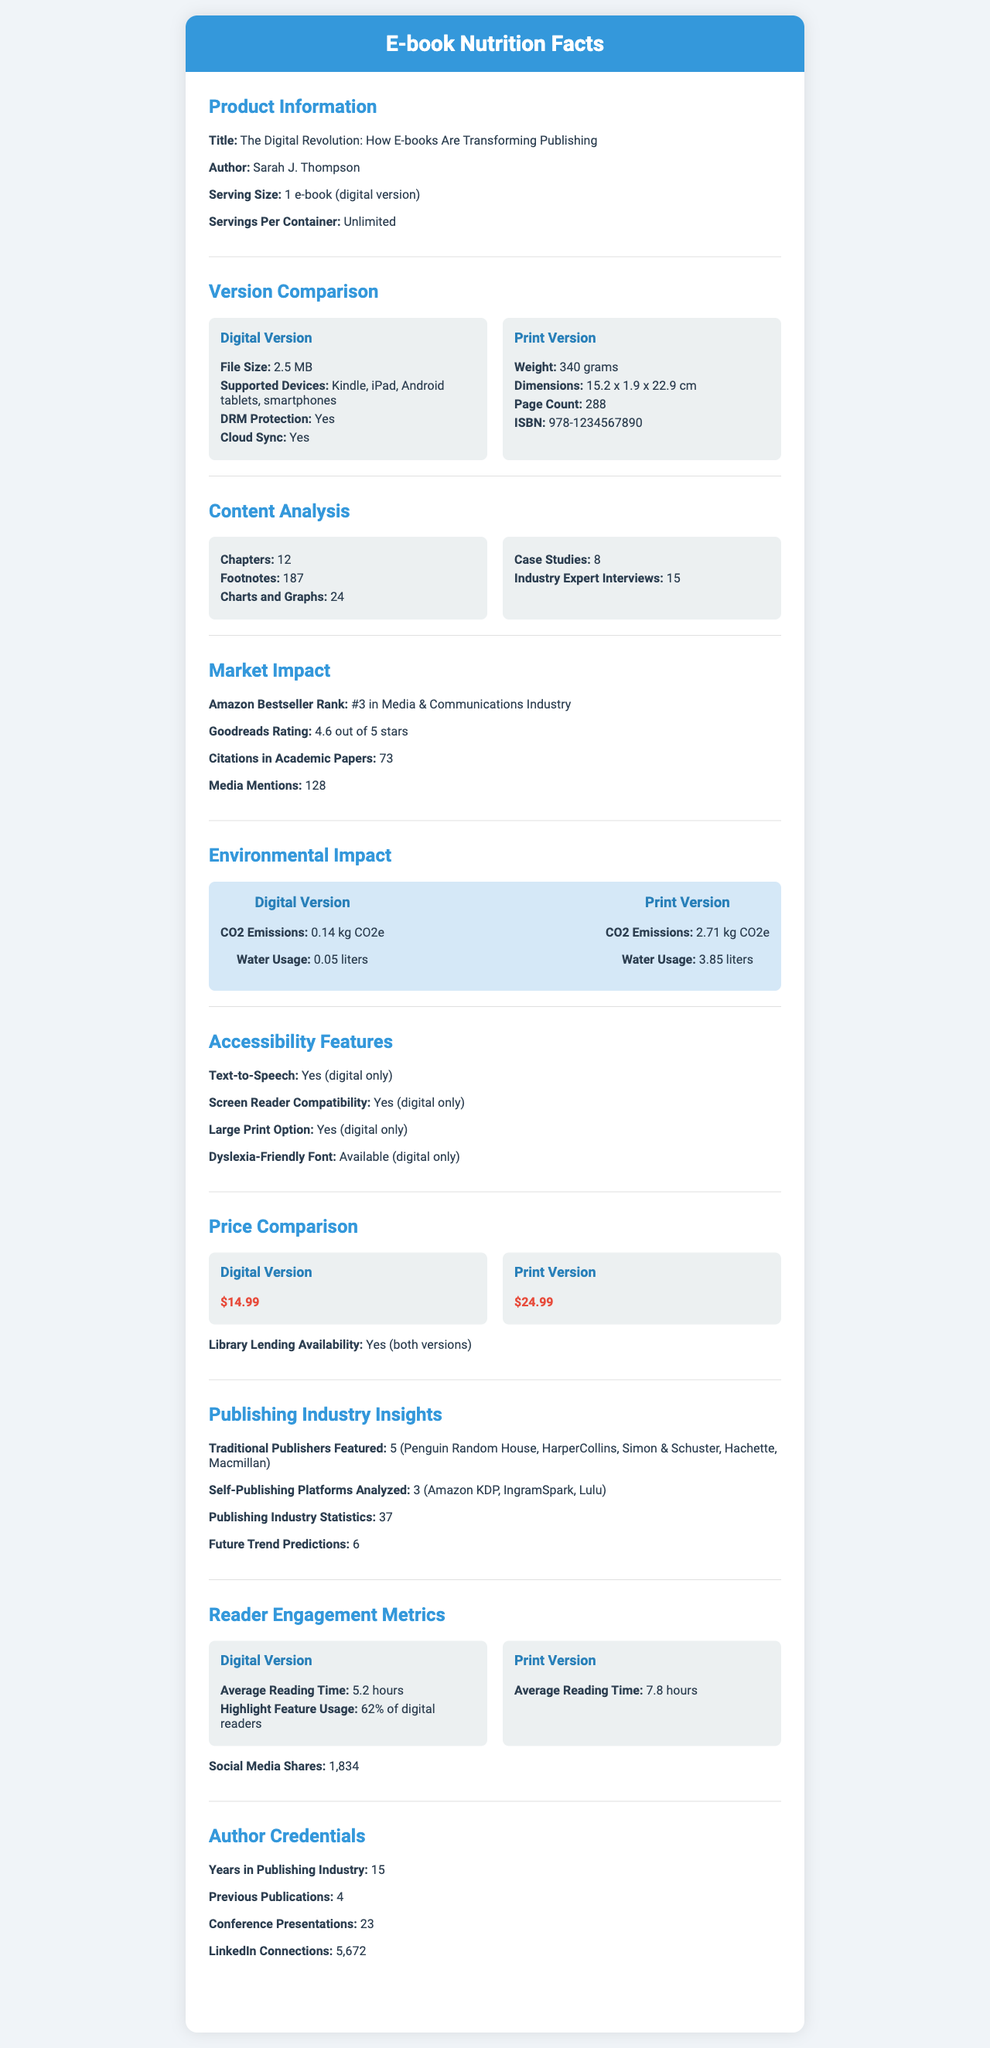what is the file size of the digital version of the e-book? The file size of the digital version is clearly mentioned under "Digital Version Info" as 2.5 MB.
Answer: 2.5 MB on which devices can the digital version of the e-book be read? The supported devices for the digital version are listed as Kindle, iPad, Android tablets, and smartphones under "Digital Version Info".
Answer: Kindle, iPad, Android tablets, smartphones how much does the print version of the e-book cost? The cost of the print version is specified under "Price Comparison" as $24.99.
Answer: $24.99 what is the average reading time for the print version? The average reading time for the print version is mentioned under "Reader Engagement Metrics" as 7.8 hours.
Answer: 7.8 hours how many chapters does the e-book have? The e-book contains 12 chapters as stated in the "Content Analysis" section.
Answer: 12 which version of the e-book has higher CO2 emissions? A. Digital Version B. Print Version C. Both have the same emissions The "Environmental Impact" section shows that the print version has 2.71 kg CO2e emissions, compared to 0.14 kg CO2e for the digital version.
Answer: B. Print Version what is the email address of the author? The document does not provide any contact information for the author, including an email address.
Answer: Cannot be determined does the e-book have multimedia content in the digital version? The digital version includes multimedia content such as embedded videos and interactive charts, as stated in "Digital Version Info".
Answer: Yes which type of content is exclusive to the digital version? A. Embedded videos B. Footnotes C. Page Count D. ISBN While footnotes, page count, and ISBN apply to both versions, embedded videos are exclusive to the digital version as highlighted in the "Multimedia Content" section of "Digital Version Info".
Answer: A. Embedded videos how many citations in academic papers does the e-book have? The e-book has been cited in academic papers 73 times, as recorded in the "Market Impact" section.
Answer: 73 does the print version offer a dyslexia-friendly font? The dyslexia-friendly font is only available in the digital version, as detailed in the "Accessibility Features" section.
Answer: No summarize the main idea of the document The document offers a detailed comparison between the digital and print versions of an e-book titled "The Digital Revolution: How E-books Are Transforming Publishing," covering various aspects like content, market impact, environmental impact, and accessibility features, thus providing insights into the benefits and drawbacks of each version.
Answer: The document provides a comprehensive "nutrition facts" style breakdown of a best-selling e-book, covering aspects like version comparisons, content analysis, market impact, environmental impact, accessibility features, price comparison, industry insights, reader engagement metrics, and author credentials. The key differences between the digital and print versions are highlighted, including file size, CO2 emissions, multimedia content, and prices. 